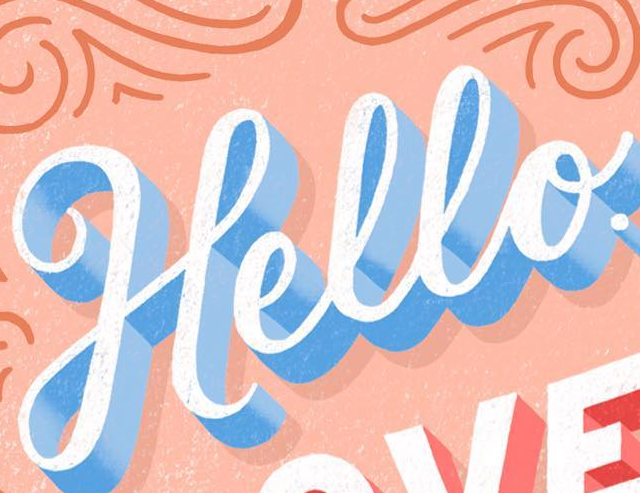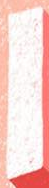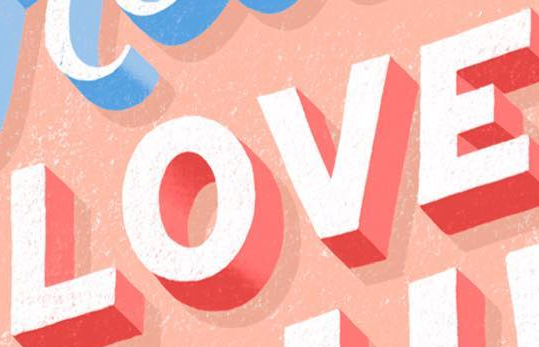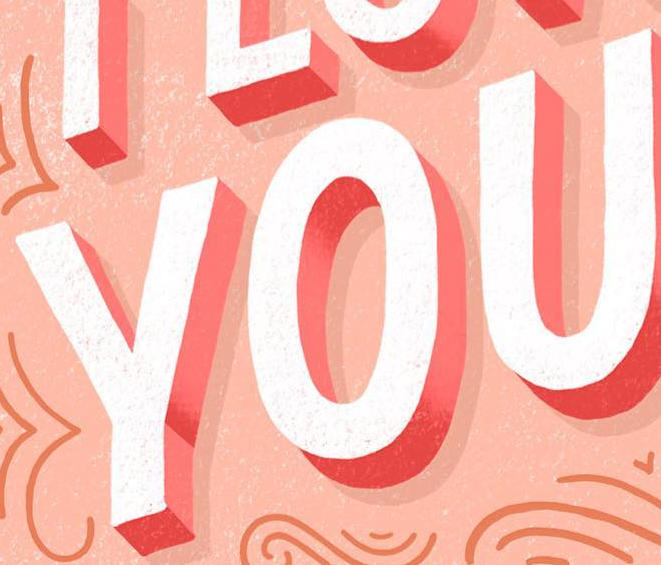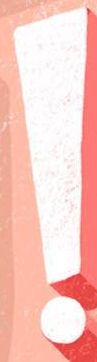What text appears in these images from left to right, separated by a semicolon? Hello; I; LOVE; YOU; ! 